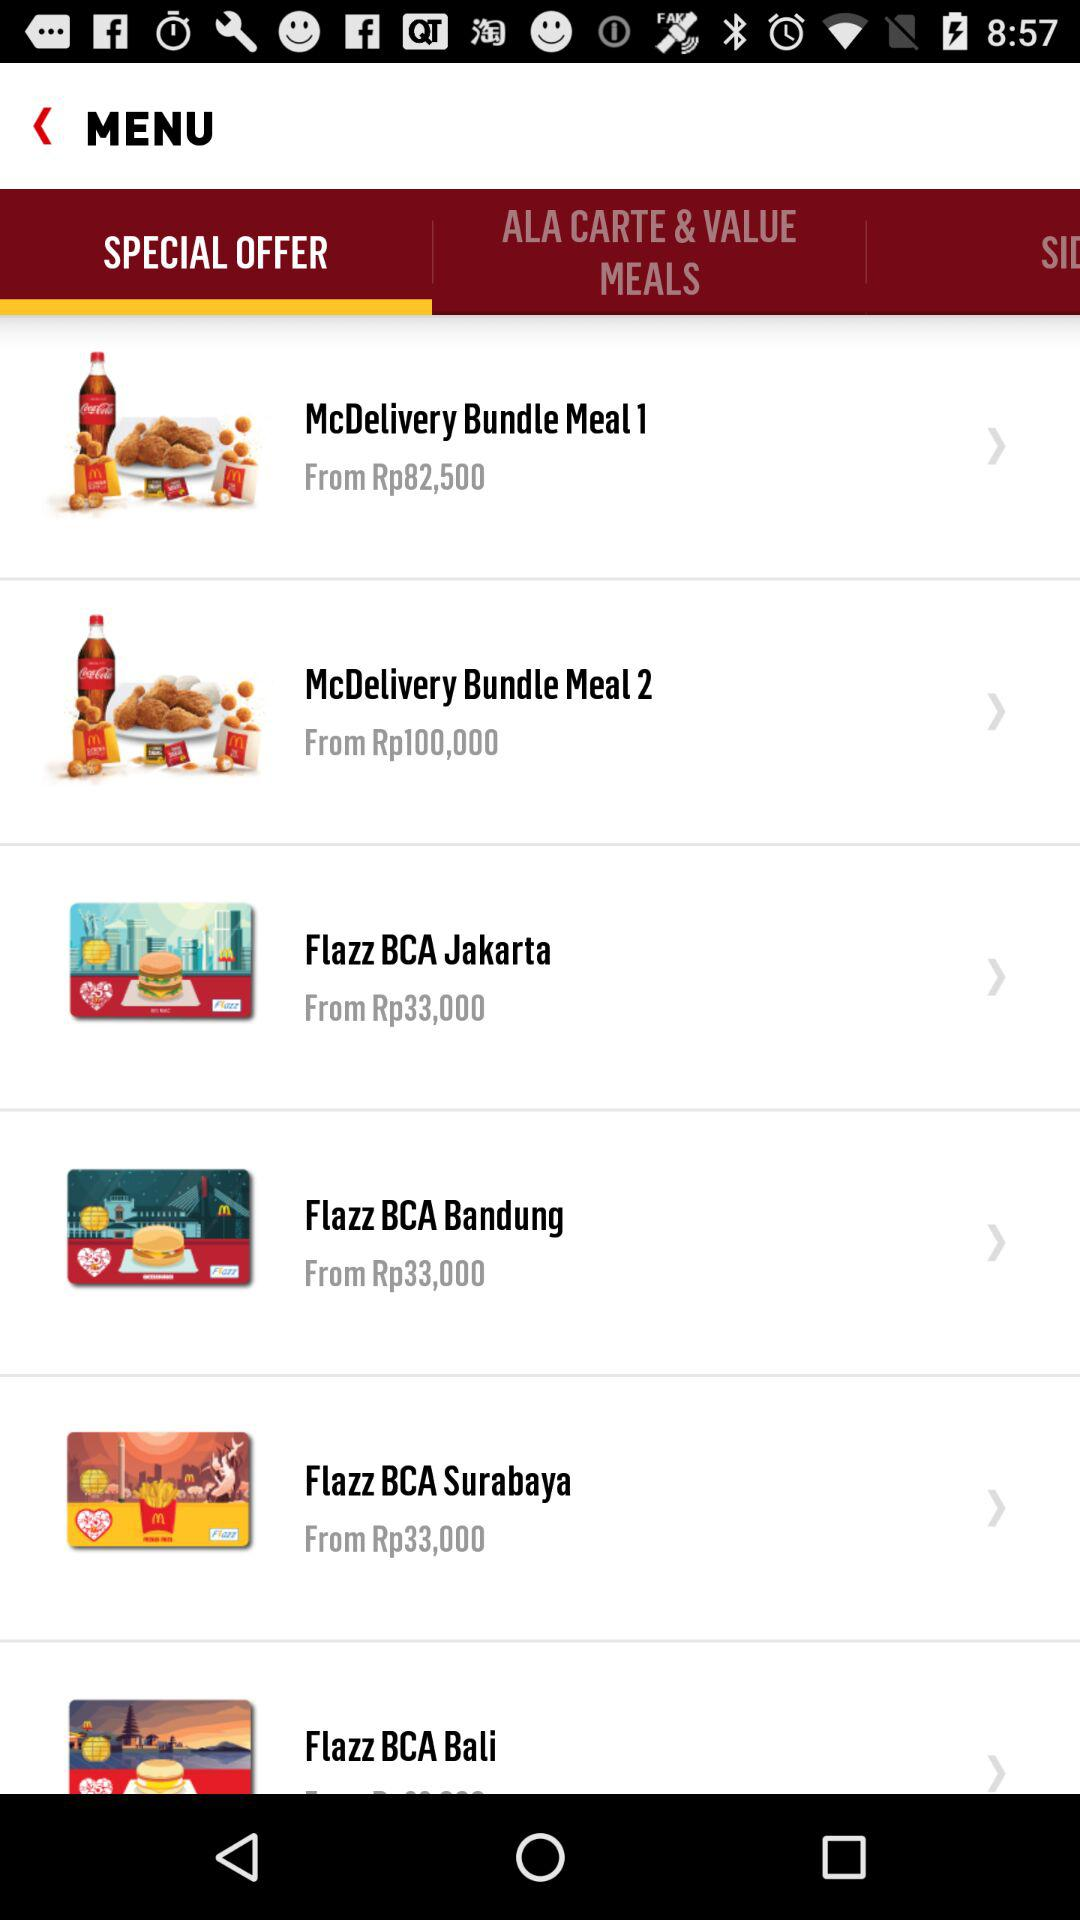What is the currency of price? The currency of price is the rupiah (Rp). 